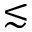<formula> <loc_0><loc_0><loc_500><loc_500>\lesssim</formula> 